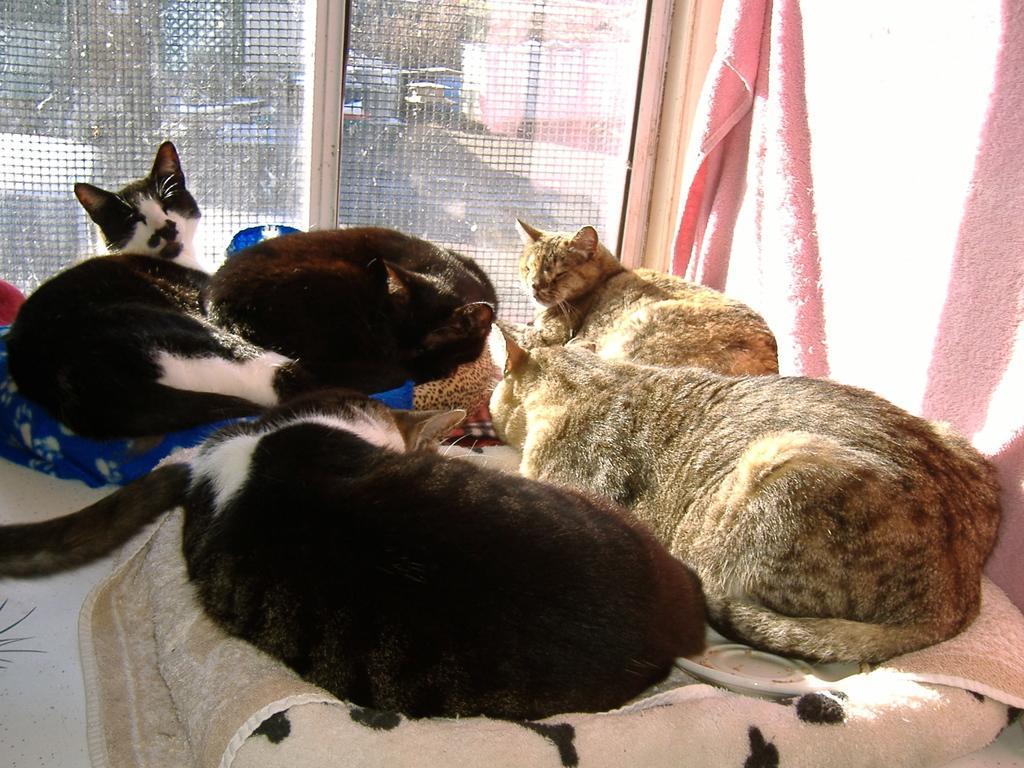How would you summarize this image in a sentence or two? In this picture I can see few cats are on the blankets. 